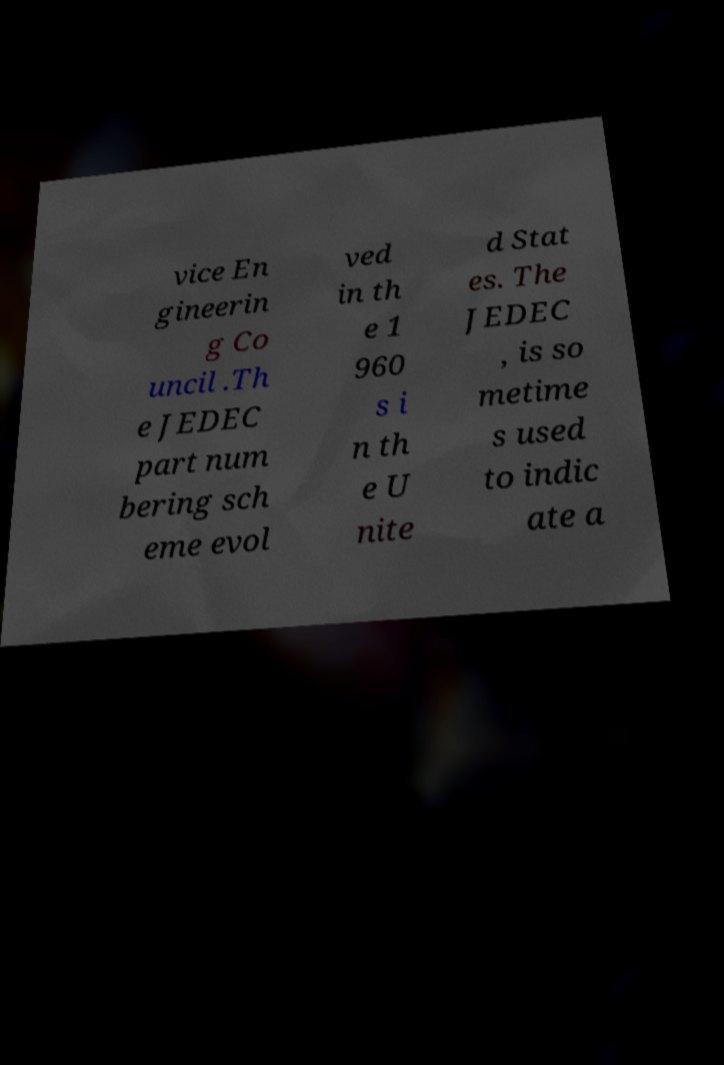I need the written content from this picture converted into text. Can you do that? vice En gineerin g Co uncil .Th e JEDEC part num bering sch eme evol ved in th e 1 960 s i n th e U nite d Stat es. The JEDEC , is so metime s used to indic ate a 